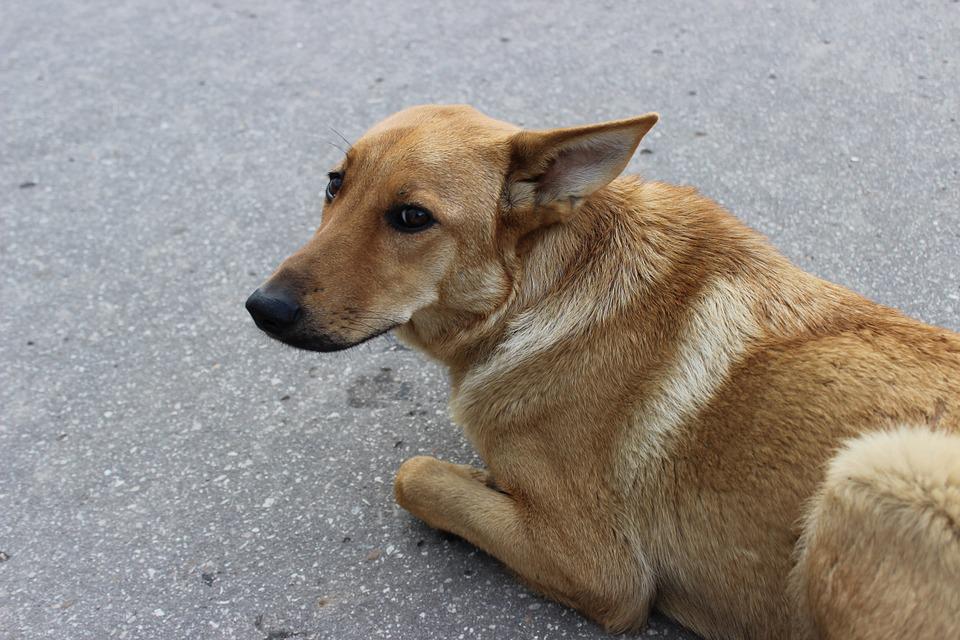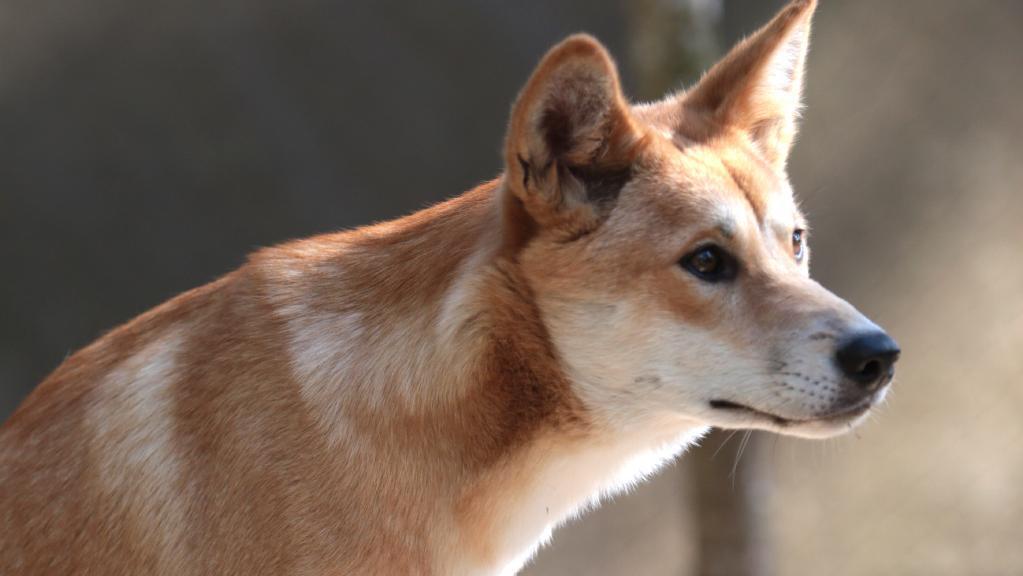The first image is the image on the left, the second image is the image on the right. Considering the images on both sides, is "The left image shows a dog gazing leftward, and the right image shows a dog whose gaze is more forward." valid? Answer yes or no. No. 